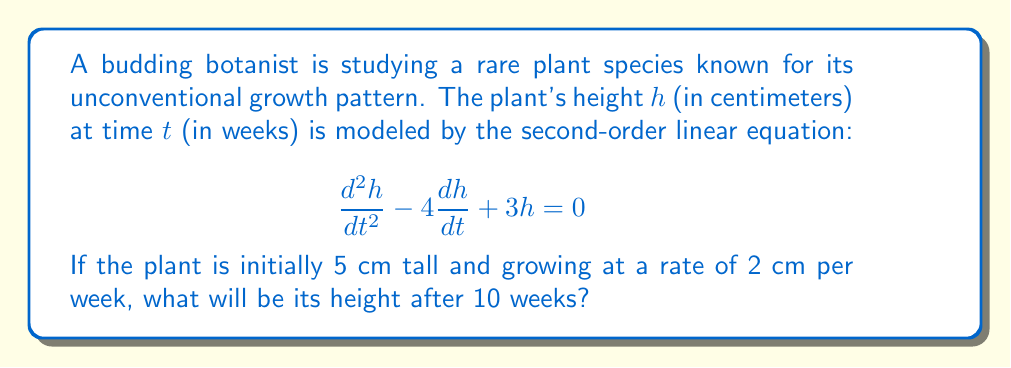Show me your answer to this math problem. Let's approach this step-by-step:

1) The general solution to this second-order linear equation is:
   $$h(t) = C_1e^{3t} + C_2e^t$$

2) We need to find $C_1$ and $C_2$ using the initial conditions:
   At $t=0$, $h(0) = 5$ and $h'(0) = 2$

3) Using the first condition:
   $$h(0) = C_1 + C_2 = 5$$

4) For the second condition, we differentiate $h(t)$:
   $$h'(t) = 3C_1e^{3t} + C_2e^t$$
   $$h'(0) = 3C_1 + C_2 = 2$$

5) Now we have a system of equations:
   $$C_1 + C_2 = 5$$
   $$3C_1 + C_2 = 2$$

6) Subtracting the first equation from the second:
   $$2C_1 = -3$$
   $$C_1 = -\frac{3}{2}$$

7) Substituting back into the first equation:
   $$-\frac{3}{2} + C_2 = 5$$
   $$C_2 = \frac{13}{2}$$

8) Our solution is therefore:
   $$h(t) = -\frac{3}{2}e^{3t} + \frac{13}{2}e^t$$

9) To find the height at 10 weeks, we substitute $t=10$:
   $$h(10) = -\frac{3}{2}e^{30} + \frac{13}{2}e^{10}$$

10) Calculating this (you may use a calculator):
    $$h(10) \approx 29,886.37 \text{ cm}$$
Answer: The height of the plant after 10 weeks will be approximately 29,886.37 cm. 